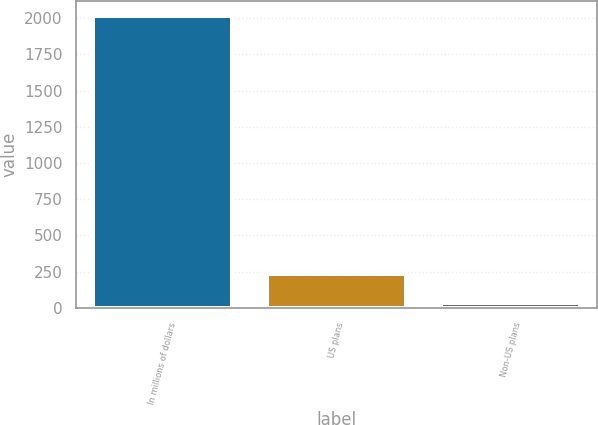<chart> <loc_0><loc_0><loc_500><loc_500><bar_chart><fcel>In millions of dollars<fcel>US plans<fcel>Non-US plans<nl><fcel>2018<fcel>230.6<fcel>32<nl></chart> 